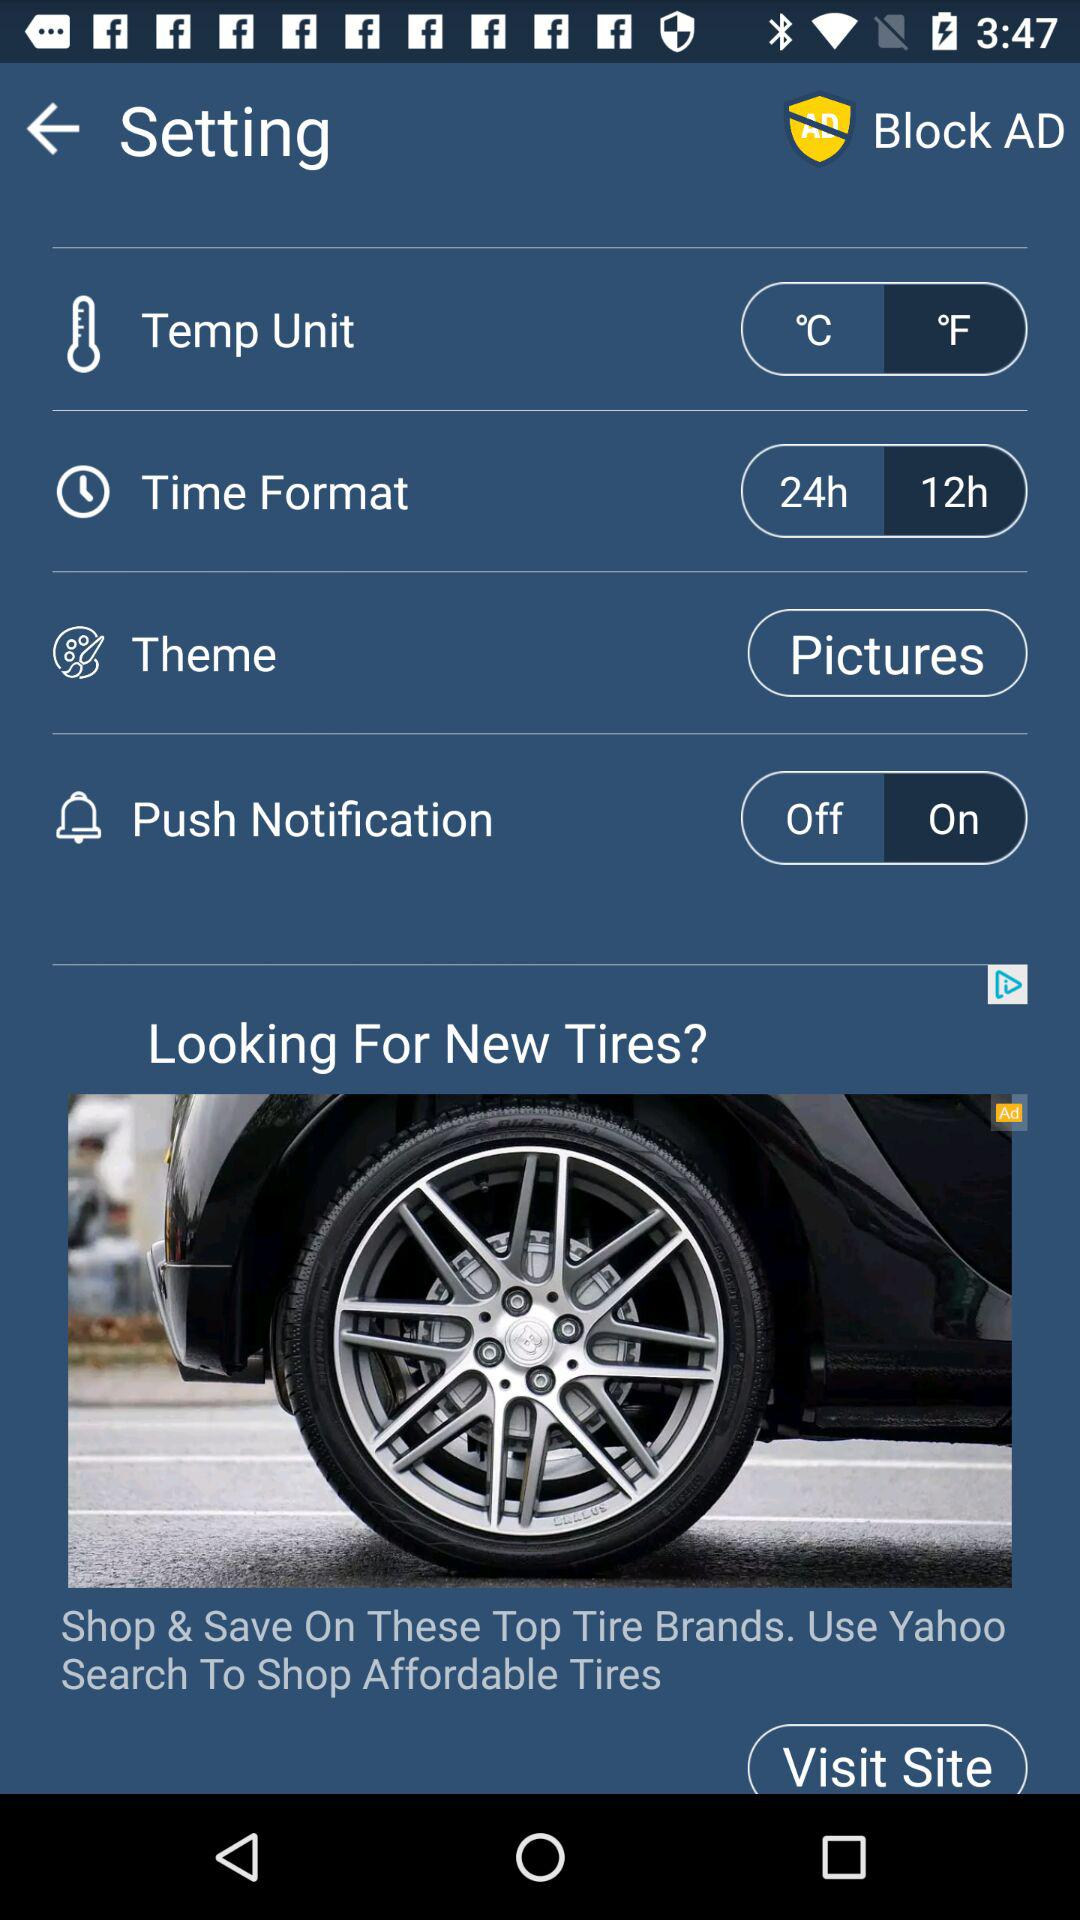Which theme is selected? The selected theme is pictures. 